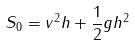<formula> <loc_0><loc_0><loc_500><loc_500>S _ { 0 } = v ^ { 2 } h + \frac { 1 } { 2 } g h ^ { 2 }</formula> 